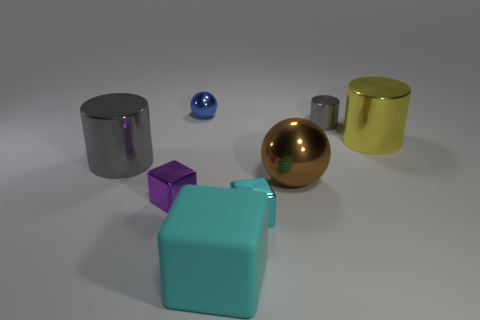There is a large thing that is the same shape as the tiny blue thing; what material is it? The large object that shares the same spherical shape as the small blue object appears to be made of polished metal, possibly stainless steel, given its reflective surface and silver color. 